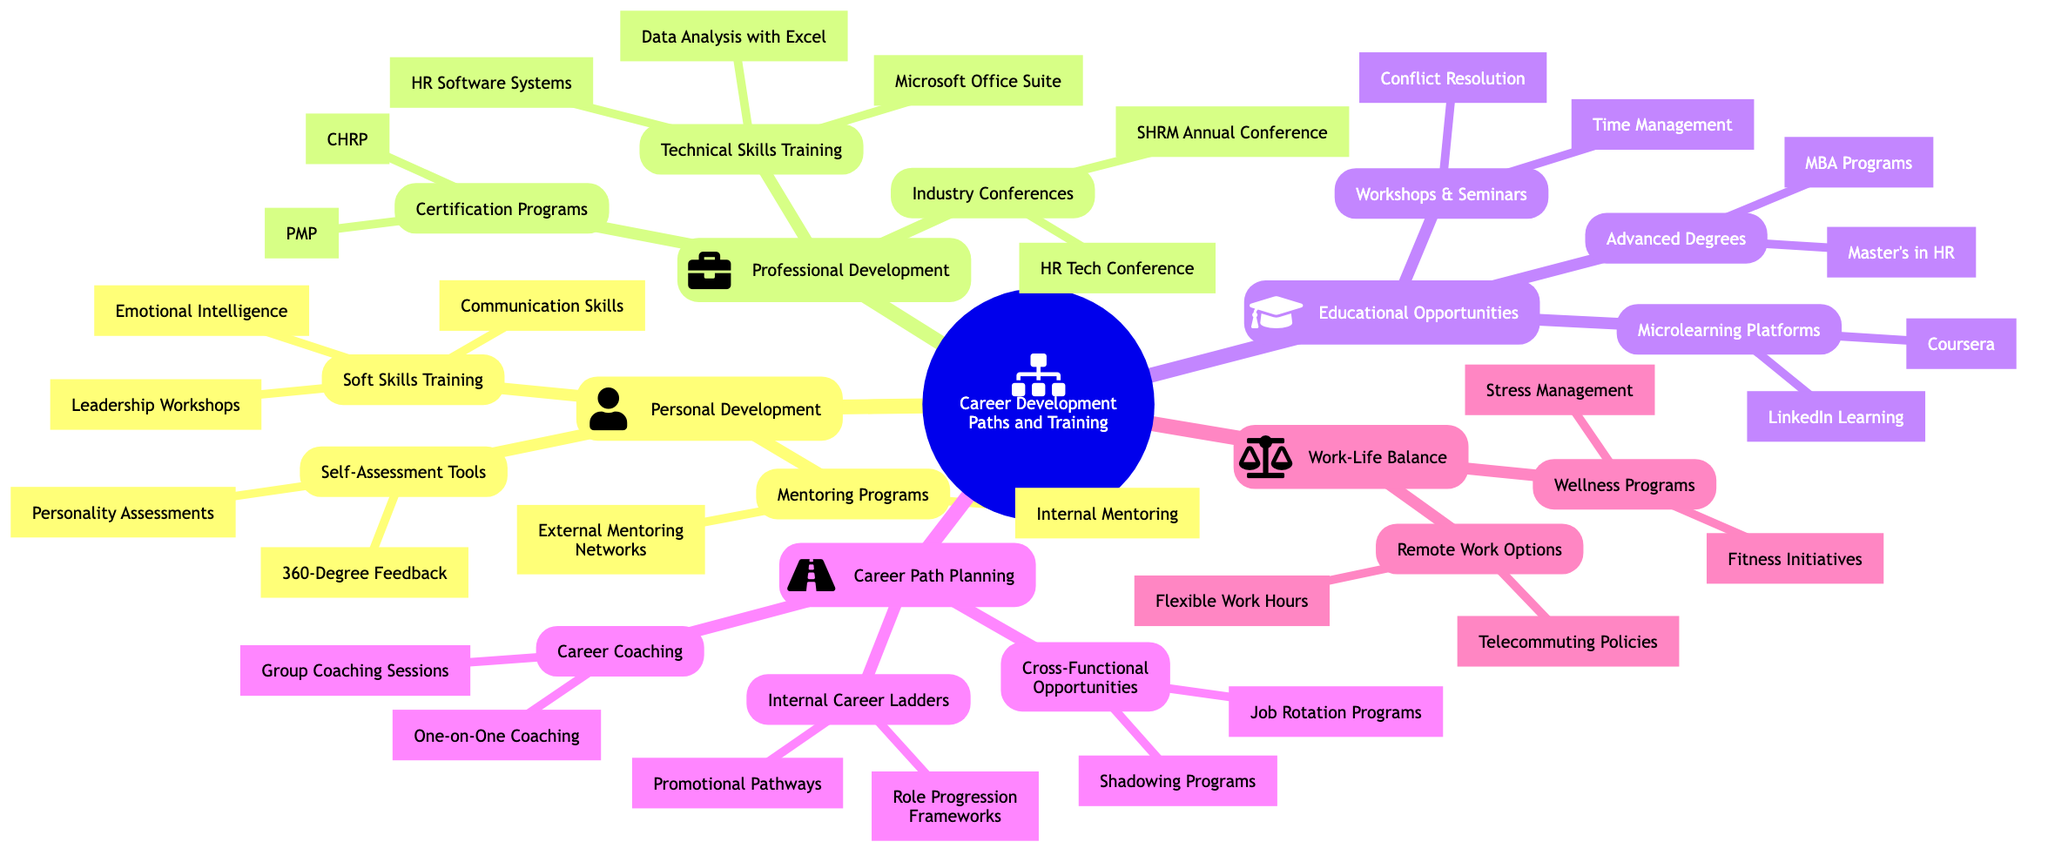What is the first level of the mind map? The first level of the mind map consists of main categories related to career development paths and training opportunities. These are labeled as "Personal Development," "Professional Development," "Educational Opportunities," "Career Path Planning," and "Work-Life Balance."
Answer: Personal Development, Professional Development, Educational Opportunities, Career Path Planning, Work-Life Balance How many types of mentoring programs are listed? In the "Mentoring Programs" section under "Personal Development," there are two types: "Internal Mentoring" and "External Mentoring Networks."
Answer: 2 What are the certification programs mentioned? The diagram indicates two certification programs under "Certification Programs" in the "Professional Development" category: "Project Management Professional (PMP)" and "Certified Human Resources Professional (CHRP)."
Answer: Project Management Professional (PMP), Certified Human Resources Professional (CHRP) Which category contains workshops and seminars? The "Workshops & Seminars" node is located under the "Educational Opportunities" category, indicating that this type of learning opportunity is classified within that section of the mind map.
Answer: Educational Opportunities What is the relationship between "Career Coaching" and "Career Path Planning"? "Career Coaching" is a subset of the "Career Path Planning" category. This means that career coaching initiatives are aimed at aiding in the planning of career paths, aligning them under the same main category.
Answer: Career Path Planning How many options are there for "Remote Work Options"? Under the "Work-Life Balance" category, there are two options listed: "Telecommuting Policies" and "Flexible Work Hours." This indicates that there are two specific policies available regarding remote working.
Answer: 2 What skills are taught in soft skills training? The "Soft Skills Training" section lists three areas of focus: "Communication Skills," "Leadership Workshops," and "Emotional Intelligence," showcasing the variety of soft skills development offered.
Answer: Communication Skills, Leadership Workshops, Emotional Intelligence Which category contains microlearning platforms? The "Microlearning Platforms" are categorized under "Educational Opportunities" in the mind map, indicating this learning style fits within a broader educational framework.
Answer: Educational Opportunities What is a type of wellness program listed? The "Wellness Programs" section under "Work-Life Balance" mentions "Stress Management Workshops" as a specific type of program aimed at enhancing employee wellness.
Answer: Stress Management Workshops 